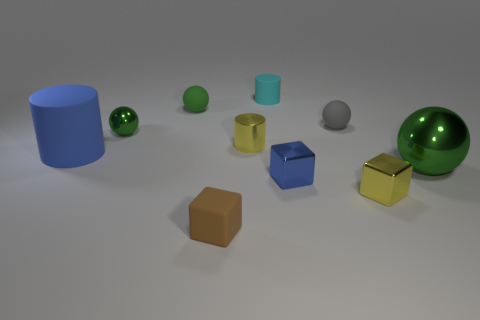Can you describe the sizes and colors of the objects starting from the left side of the image? On the left side, there's a large blue cylindrical object, followed by a small green matte ball, a small teal cylinder, a small grey sphere, and a medium-sized green metallic ball. Further right, there's a large green cylinder, a small blue cube, and a small yellow cube with a metallic sheen. 